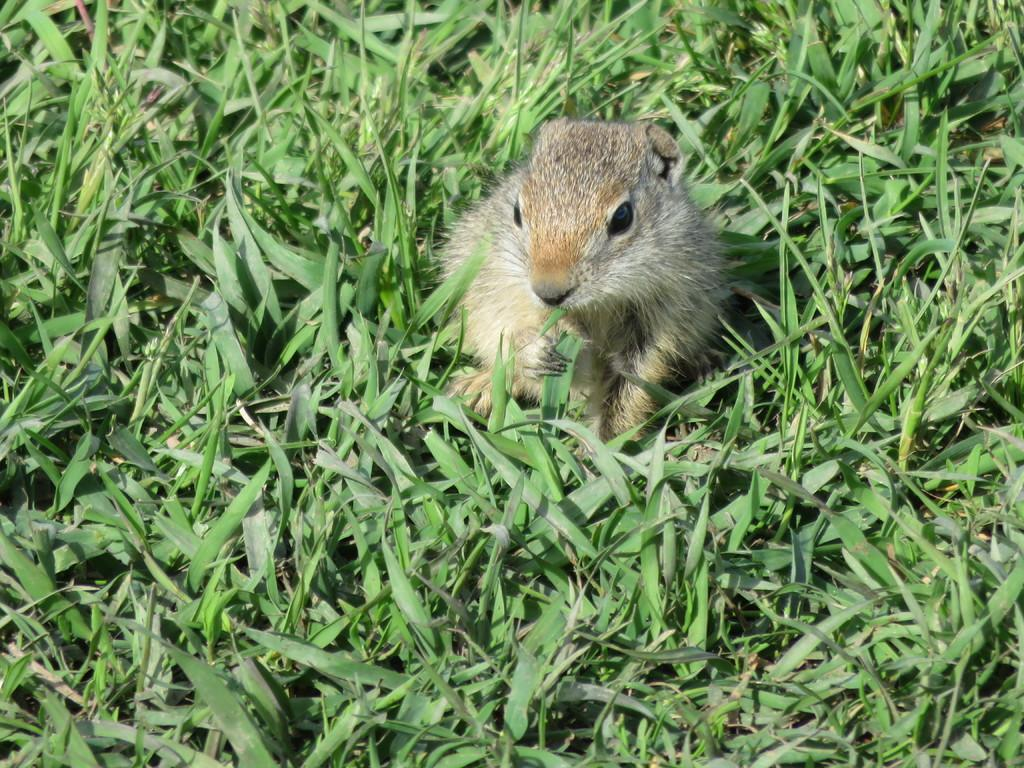What animal can be seen in the picture? There is a squirrel in the picture. What is the squirrel holding in its mouth? The squirrel is holding a green leaf. What type of vegetation is present in the picture? There are plants in the picture. What type of flowers can be seen growing on the squirrel's back in the image? There are no flowers visible on the squirrel's back in the image. 